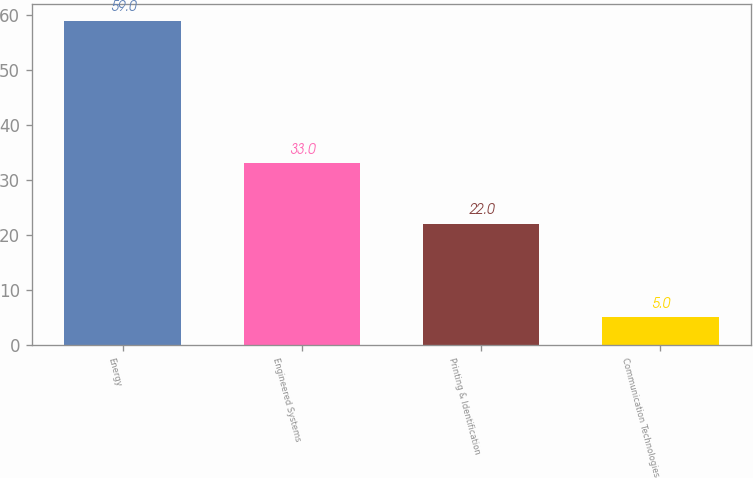Convert chart. <chart><loc_0><loc_0><loc_500><loc_500><bar_chart><fcel>Energy<fcel>Engineered Systems<fcel>Printing & Identification<fcel>Communication Technologies<nl><fcel>59<fcel>33<fcel>22<fcel>5<nl></chart> 